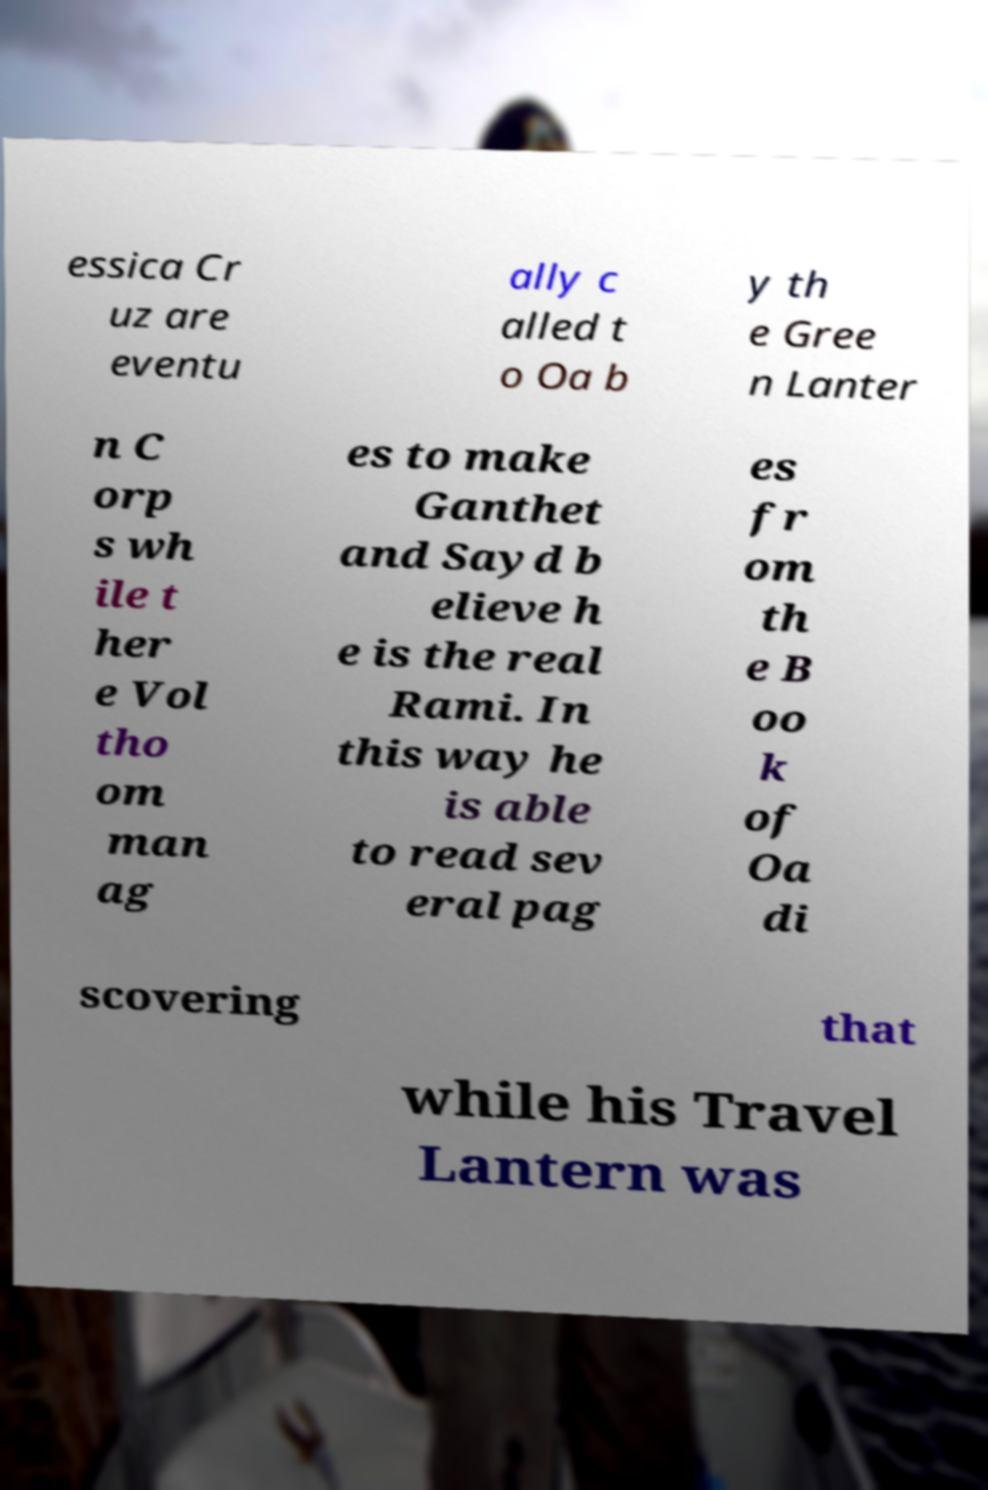Can you accurately transcribe the text from the provided image for me? essica Cr uz are eventu ally c alled t o Oa b y th e Gree n Lanter n C orp s wh ile t her e Vol tho om man ag es to make Ganthet and Sayd b elieve h e is the real Rami. In this way he is able to read sev eral pag es fr om th e B oo k of Oa di scovering that while his Travel Lantern was 